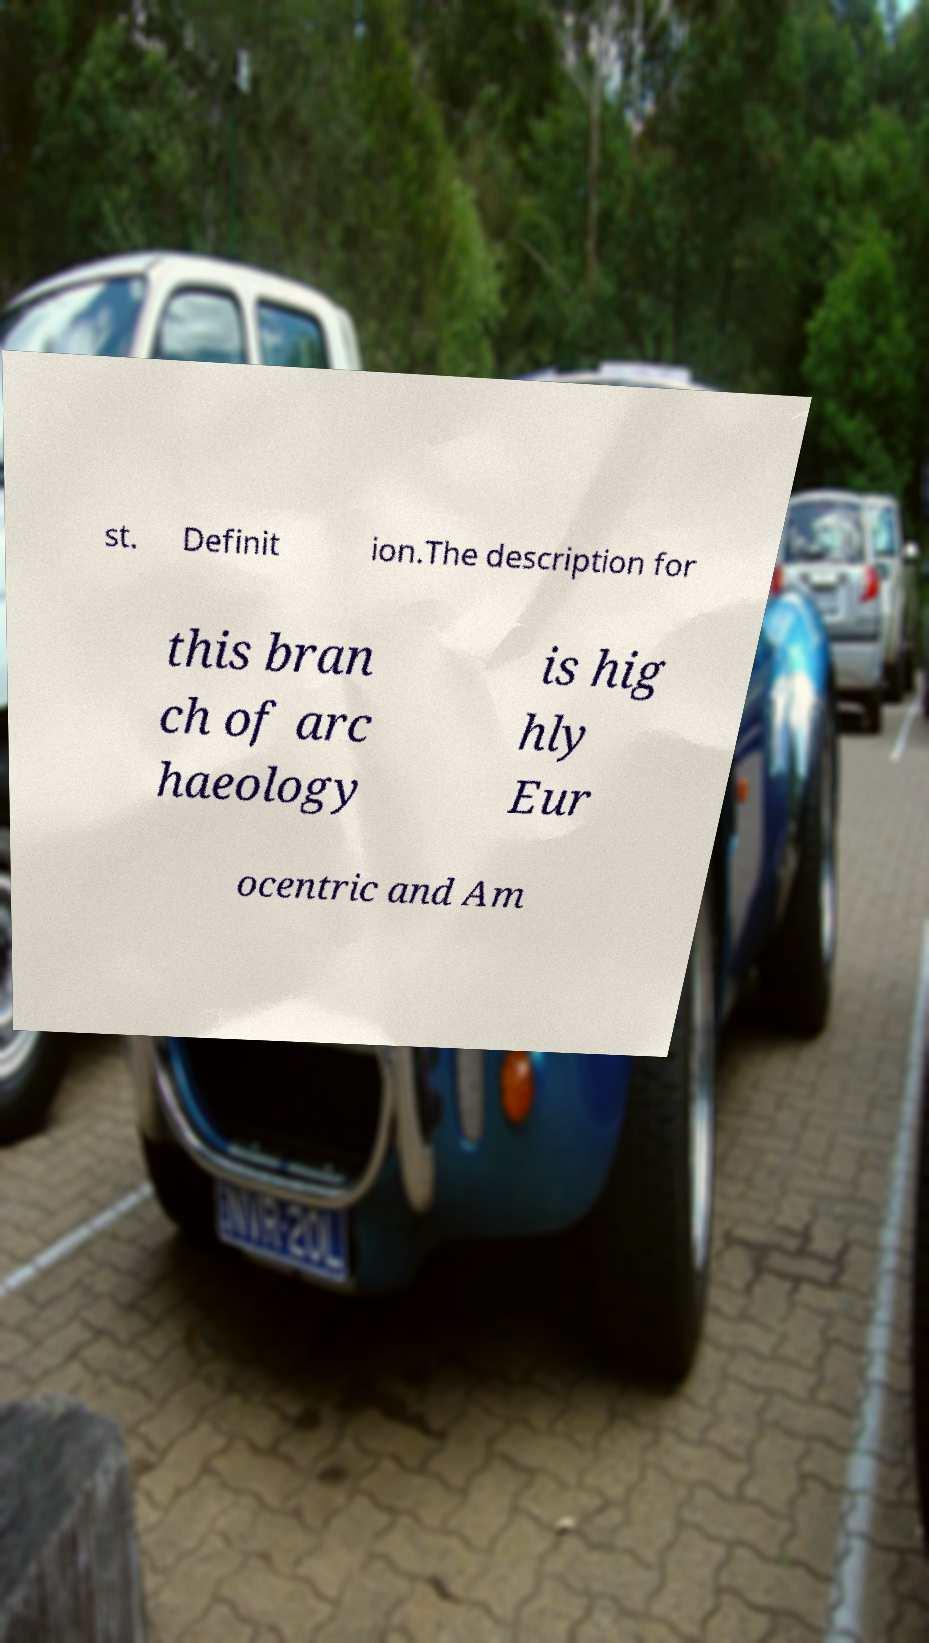Could you extract and type out the text from this image? st. Definit ion.The description for this bran ch of arc haeology is hig hly Eur ocentric and Am 